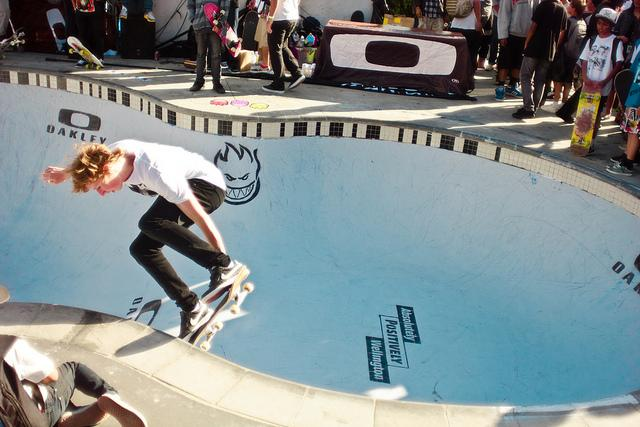What's happening to this guy?

Choices:
A) bouncing
B) being chased
C) falling
D) doing tricks doing tricks 